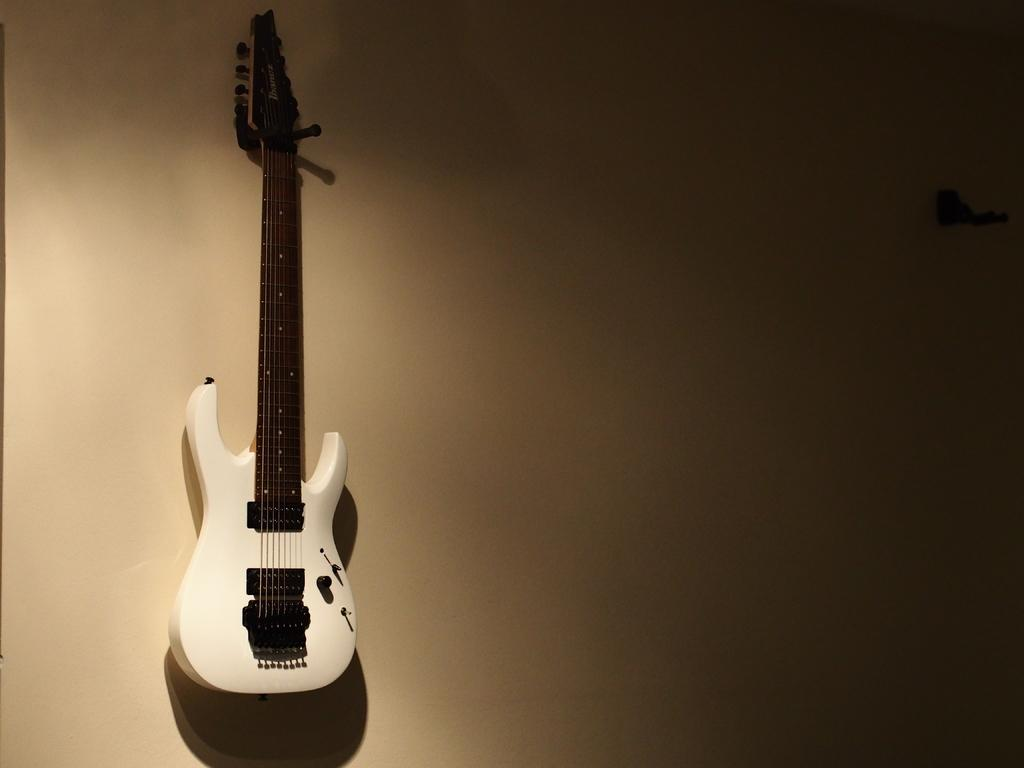What musical instrument is in the image? There is a guitar in the image. Where is the guitar located? The guitar is on the wall. Can you see a cat playing with the guitar strings in the image? There is no cat present in the image, and the guitar is on the wall, so it is not possible for a cat to play with the guitar strings. 